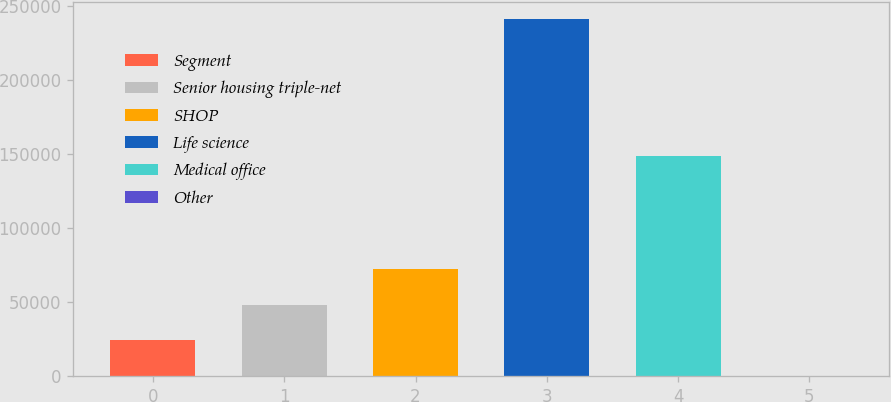<chart> <loc_0><loc_0><loc_500><loc_500><bar_chart><fcel>Segment<fcel>Senior housing triple-net<fcel>SHOP<fcel>Life science<fcel>Medical office<fcel>Other<nl><fcel>24211.6<fcel>48288.2<fcel>72364.8<fcel>240901<fcel>148926<fcel>135<nl></chart> 